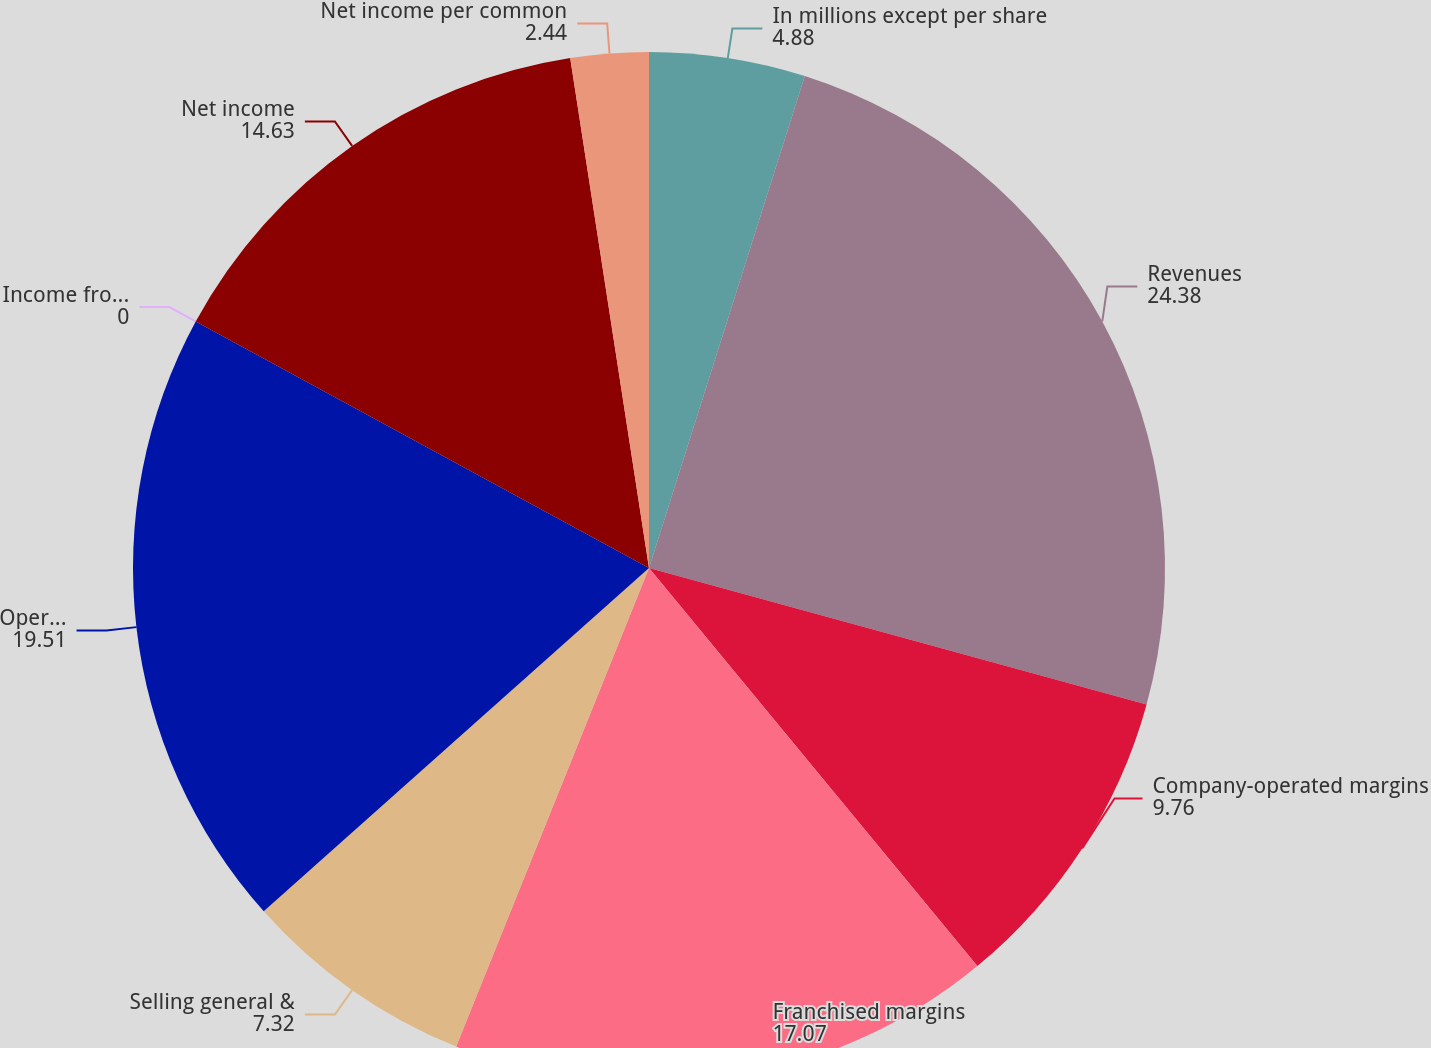Convert chart to OTSL. <chart><loc_0><loc_0><loc_500><loc_500><pie_chart><fcel>In millions except per share<fcel>Revenues<fcel>Company-operated margins<fcel>Franchised margins<fcel>Selling general &<fcel>Operating income<fcel>Income from continuing<fcel>Net income<fcel>Net income per common<nl><fcel>4.88%<fcel>24.38%<fcel>9.76%<fcel>17.07%<fcel>7.32%<fcel>19.51%<fcel>0.0%<fcel>14.63%<fcel>2.44%<nl></chart> 